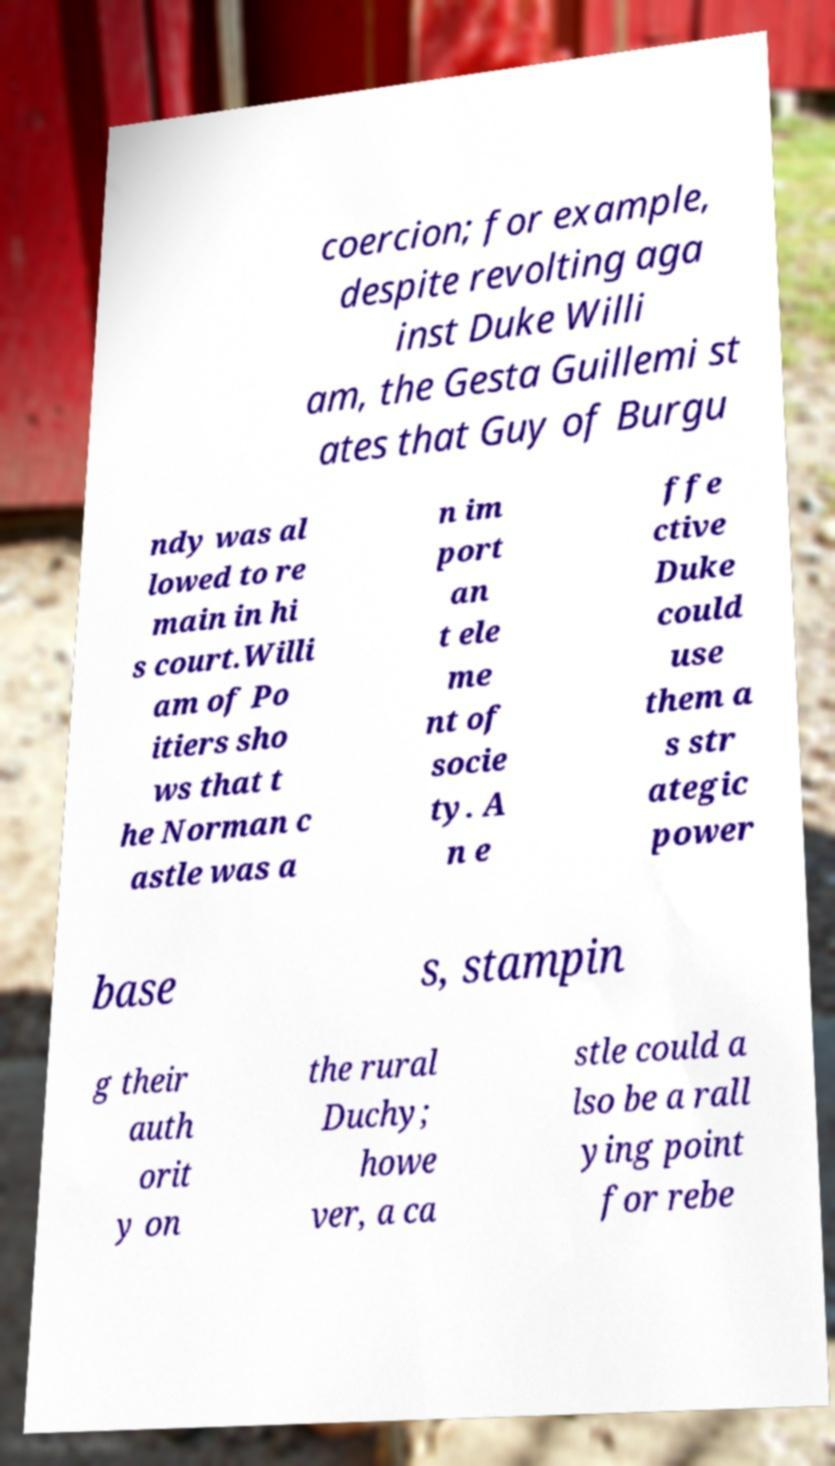I need the written content from this picture converted into text. Can you do that? coercion; for example, despite revolting aga inst Duke Willi am, the Gesta Guillemi st ates that Guy of Burgu ndy was al lowed to re main in hi s court.Willi am of Po itiers sho ws that t he Norman c astle was a n im port an t ele me nt of socie ty. A n e ffe ctive Duke could use them a s str ategic power base s, stampin g their auth orit y on the rural Duchy; howe ver, a ca stle could a lso be a rall ying point for rebe 